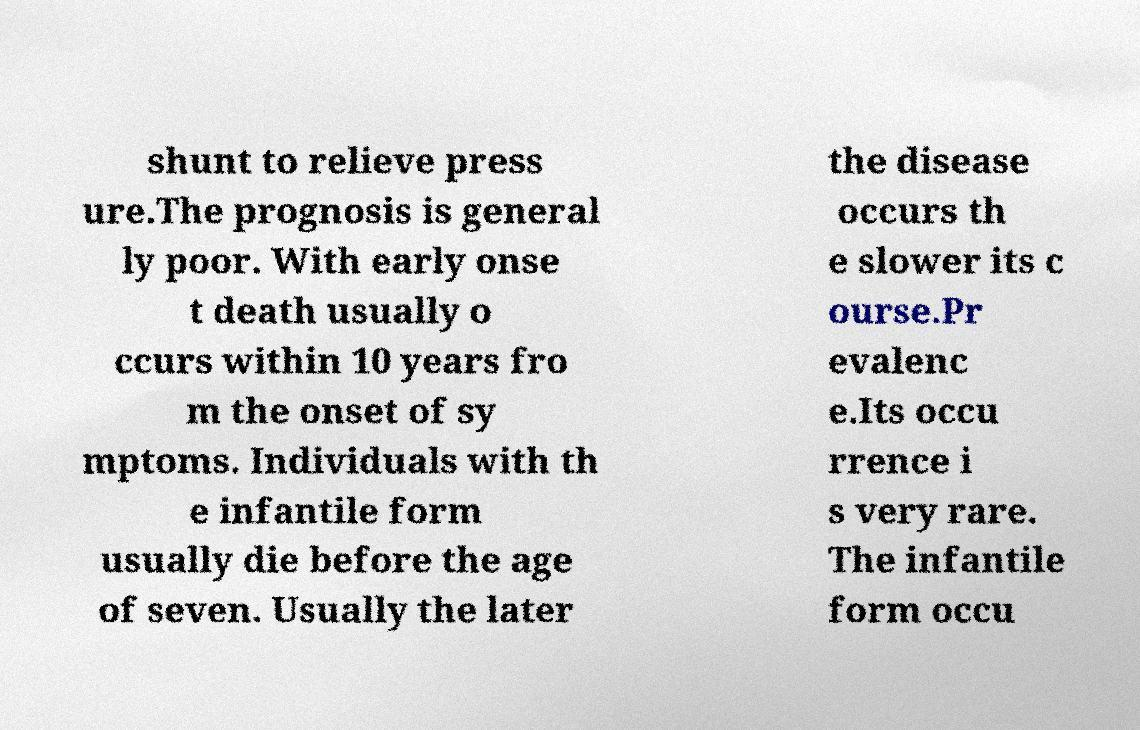There's text embedded in this image that I need extracted. Can you transcribe it verbatim? shunt to relieve press ure.The prognosis is general ly poor. With early onse t death usually o ccurs within 10 years fro m the onset of sy mptoms. Individuals with th e infantile form usually die before the age of seven. Usually the later the disease occurs th e slower its c ourse.Pr evalenc e.Its occu rrence i s very rare. The infantile form occu 